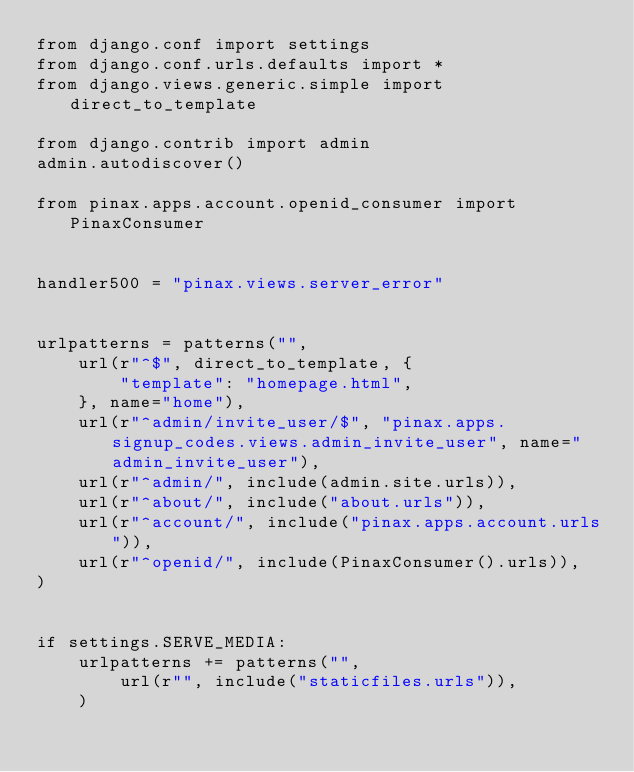<code> <loc_0><loc_0><loc_500><loc_500><_Python_>from django.conf import settings
from django.conf.urls.defaults import *
from django.views.generic.simple import direct_to_template

from django.contrib import admin
admin.autodiscover()

from pinax.apps.account.openid_consumer import PinaxConsumer


handler500 = "pinax.views.server_error"


urlpatterns = patterns("",
    url(r"^$", direct_to_template, {
        "template": "homepage.html",
    }, name="home"),
    url(r"^admin/invite_user/$", "pinax.apps.signup_codes.views.admin_invite_user", name="admin_invite_user"),
    url(r"^admin/", include(admin.site.urls)),
    url(r"^about/", include("about.urls")),
    url(r"^account/", include("pinax.apps.account.urls")),
    url(r"^openid/", include(PinaxConsumer().urls)),
)


if settings.SERVE_MEDIA:
    urlpatterns += patterns("",
        url(r"", include("staticfiles.urls")),
    )
</code> 